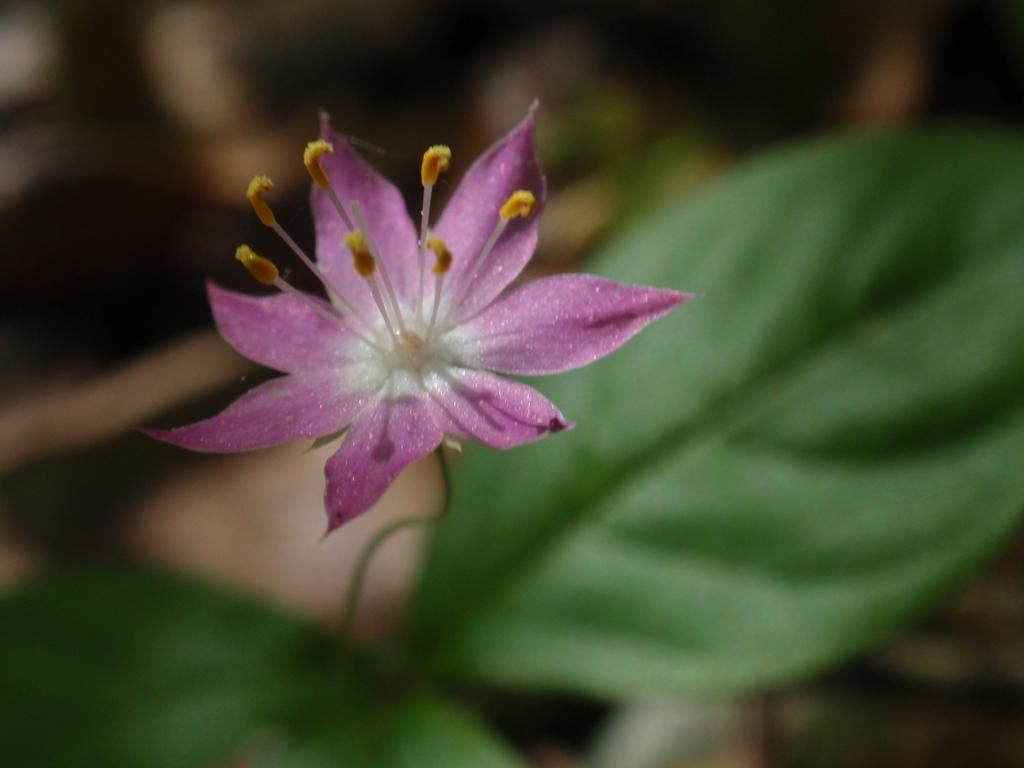How would you summarize this image in a sentence or two? In this image there is a flower to the stem of a plant. 